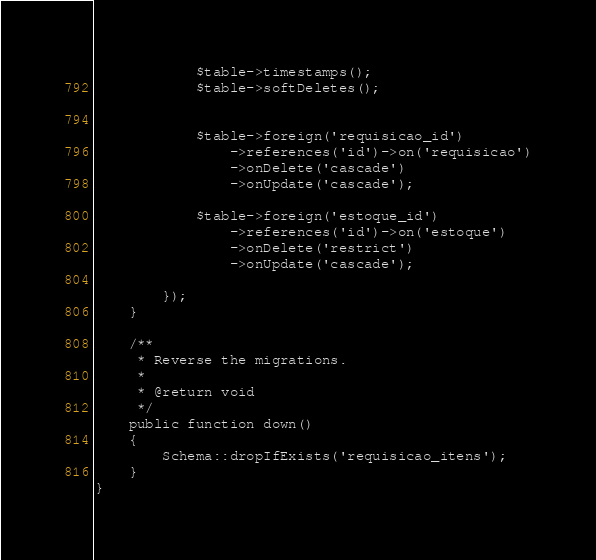Convert code to text. <code><loc_0><loc_0><loc_500><loc_500><_PHP_>            $table->timestamps();
            $table->softDeletes();


            $table->foreign('requisicao_id')
                ->references('id')->on('requisicao')
                ->onDelete('cascade')
                ->onUpdate('cascade');

            $table->foreign('estoque_id')
                ->references('id')->on('estoque')
                ->onDelete('restrict')
                ->onUpdate('cascade');

        });
    }

    /**
     * Reverse the migrations.
     *
     * @return void
     */
    public function down()
    {
        Schema::dropIfExists('requisicao_itens');
    }
}
</code> 